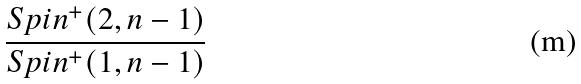<formula> <loc_0><loc_0><loc_500><loc_500>\frac { S p i n ^ { + } ( 2 , n - 1 ) } { S p i n ^ { + } ( 1 , n - 1 ) }</formula> 